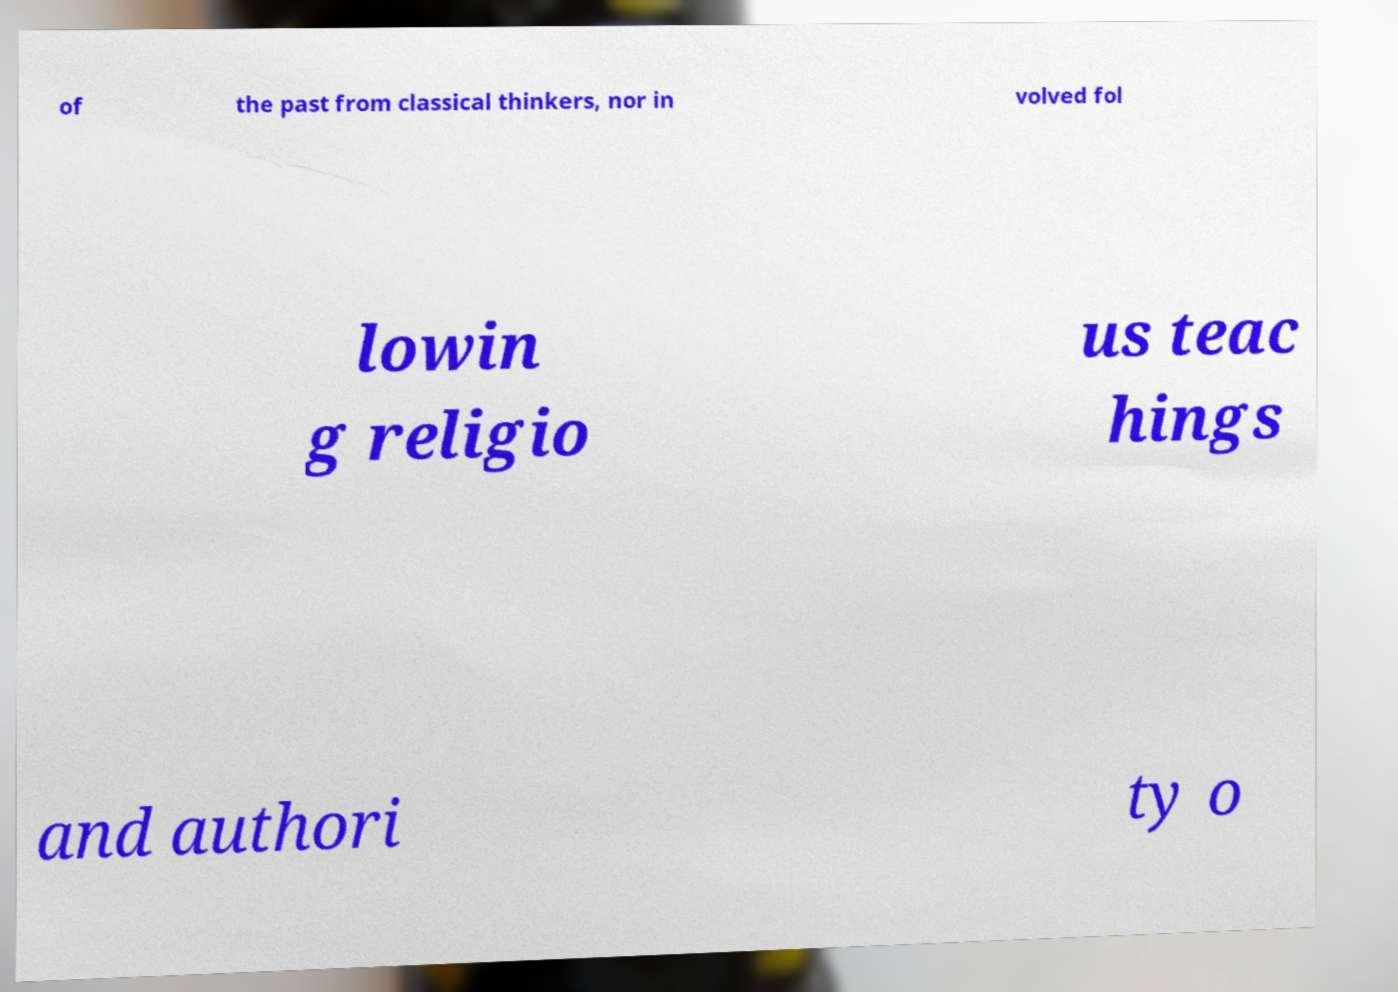Can you accurately transcribe the text from the provided image for me? of the past from classical thinkers, nor in volved fol lowin g religio us teac hings and authori ty o 